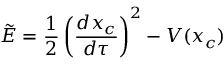Convert formula to latex. <formula><loc_0><loc_0><loc_500><loc_500>\tilde { E } = { \frac { 1 } { 2 } } \left ( { \frac { d x _ { c } } { d \tau } } \right ) ^ { 2 } - V ( x _ { c } )</formula> 